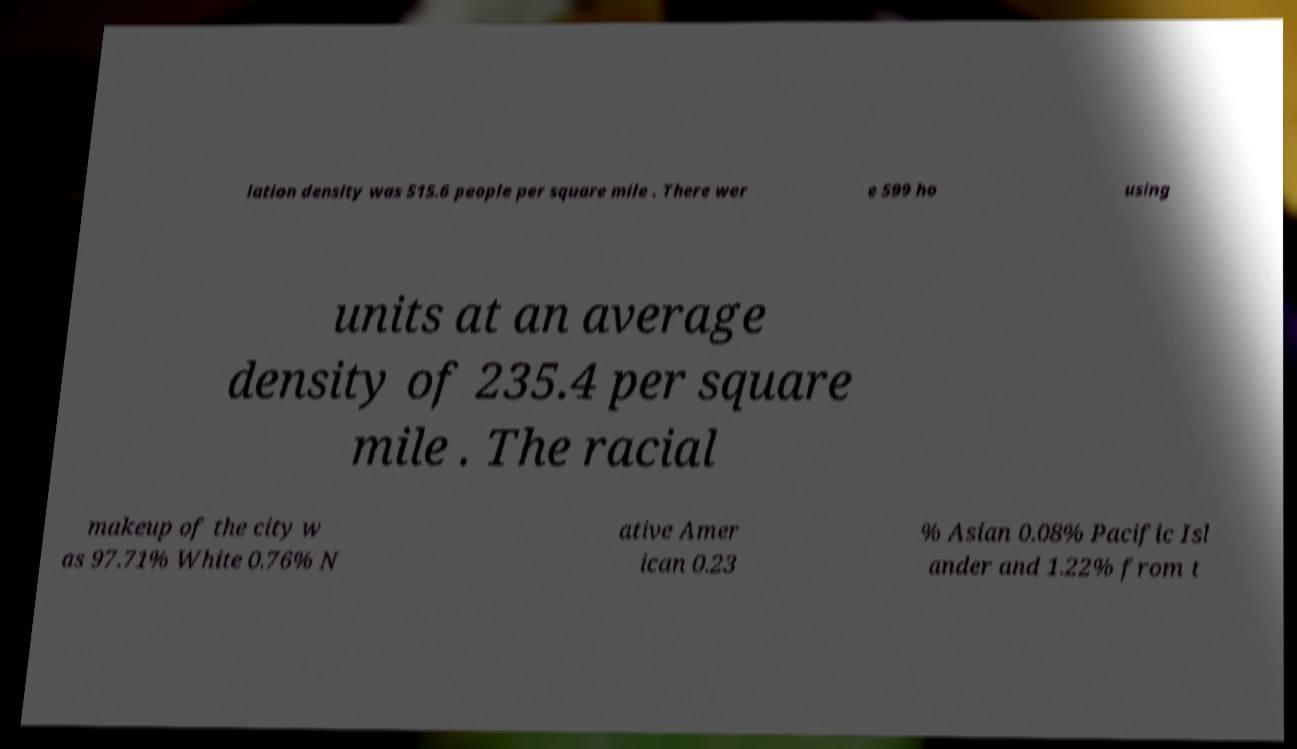Can you read and provide the text displayed in the image?This photo seems to have some interesting text. Can you extract and type it out for me? lation density was 515.6 people per square mile . There wer e 599 ho using units at an average density of 235.4 per square mile . The racial makeup of the city w as 97.71% White 0.76% N ative Amer ican 0.23 % Asian 0.08% Pacific Isl ander and 1.22% from t 